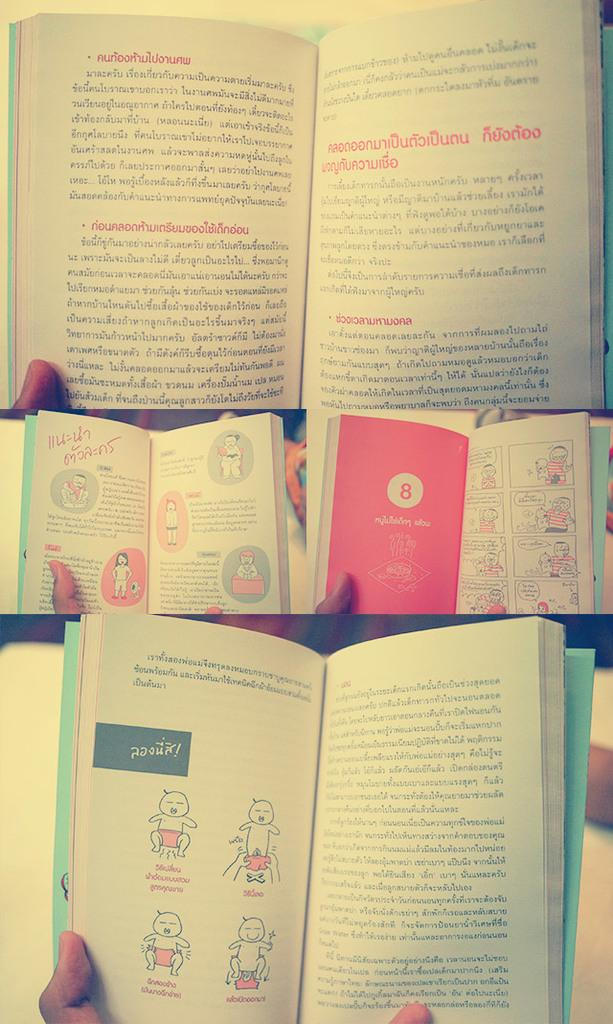<image>
Render a clear and concise summary of the photo. A book with a cartoon drawing of a man and a baby has a red page with a number 8 on it. 